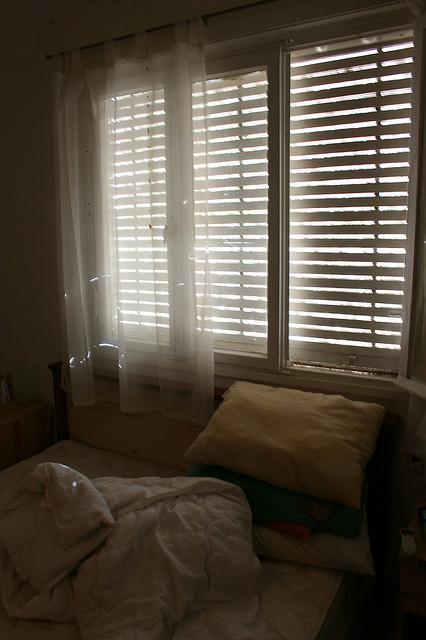Are there blinds in this picture?
Answer briefly. Yes. What is hanging on the windows?
Be succinct. Blinds. Are these curtains sheer?
Write a very short answer. Yes. Is the bed made?
Answer briefly. No. What color is the curtains?
Give a very brief answer. White. Is the bed neatly done?
Quick response, please. No. 